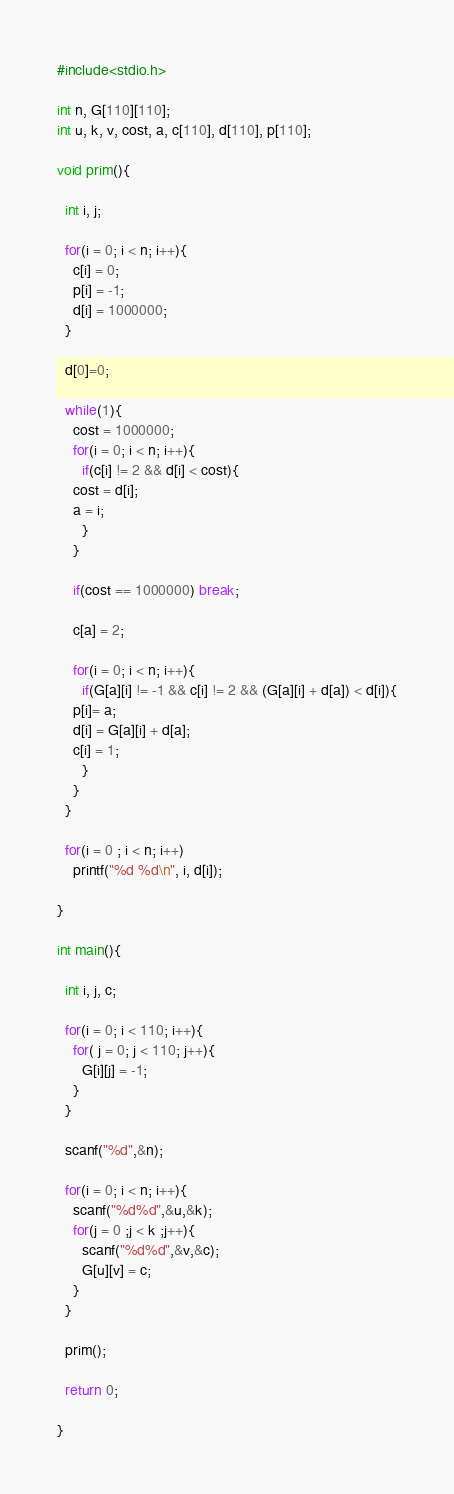<code> <loc_0><loc_0><loc_500><loc_500><_C_>#include<stdio.h>
    
int n, G[110][110];
int u, k, v, cost, a, c[110], d[110], p[110];
  
void prim(){
  
  int i, j;
  
  for(i = 0; i < n; i++){
    c[i] = 0;
    p[i] = -1;
    d[i] = 1000000;
  }
    
  d[0]=0;
    
  while(1){
    cost = 1000000;
    for(i = 0; i < n; i++){
      if(c[i] != 2 && d[i] < cost){
    cost = d[i];
    a = i;
      }
    }
      
    if(cost == 1000000) break;
         
    c[a] = 2;
    
    for(i = 0; i < n; i++){
      if(G[a][i] != -1 && c[i] != 2 && (G[a][i] + d[a]) < d[i]){
    p[i]= a;
    d[i] = G[a][i] + d[a];
    c[i] = 1;
      }
    }
  }
    
  for(i = 0 ; i < n; i++)
    printf("%d %d\n", i, d[i]);
  
}
  
int main(){
   
  int i, j, c;
    
  for(i = 0; i < 110; i++){
    for( j = 0; j < 110; j++){
      G[i][j] = -1;
    }
  } 
  
  scanf("%d",&n);
    
  for(i = 0; i < n; i++){
    scanf("%d%d",&u,&k);
    for(j = 0 ;j < k ;j++){
      scanf("%d%d",&v,&c);
      G[u][v] = c;
    }
  }
    
  prim();
    
  return 0;
   
}

</code> 